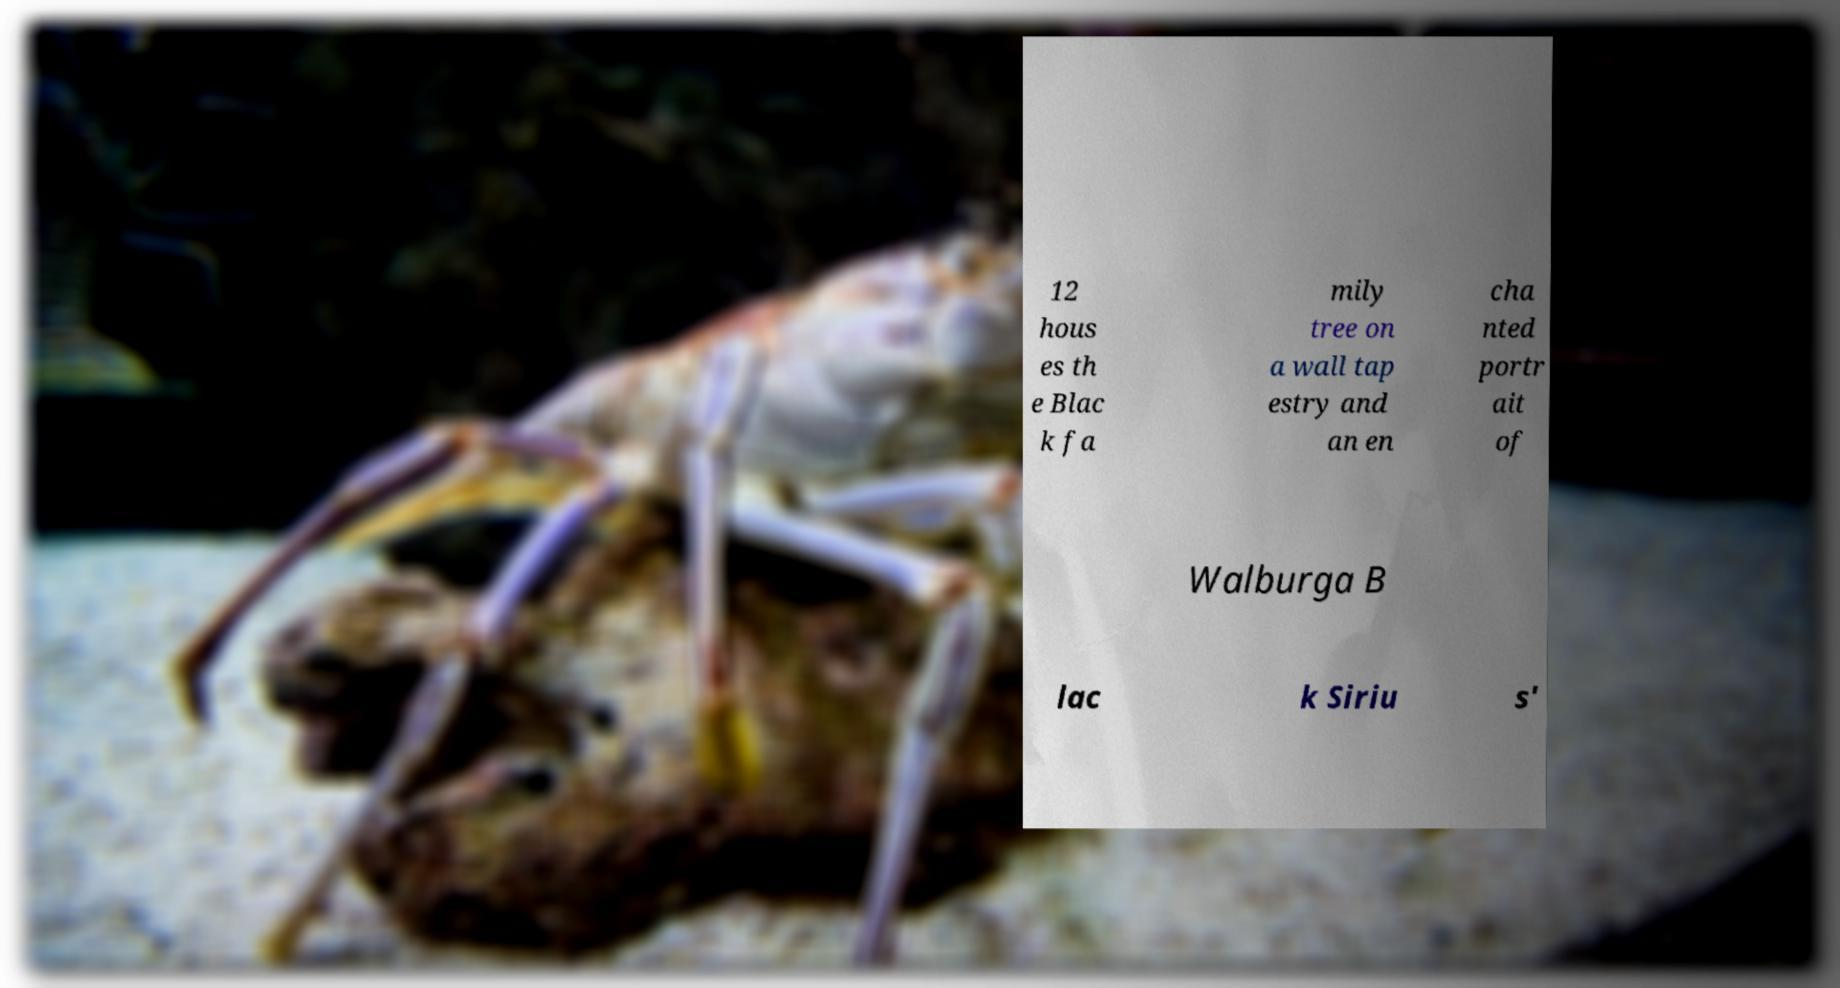There's text embedded in this image that I need extracted. Can you transcribe it verbatim? 12 hous es th e Blac k fa mily tree on a wall tap estry and an en cha nted portr ait of Walburga B lac k Siriu s' 